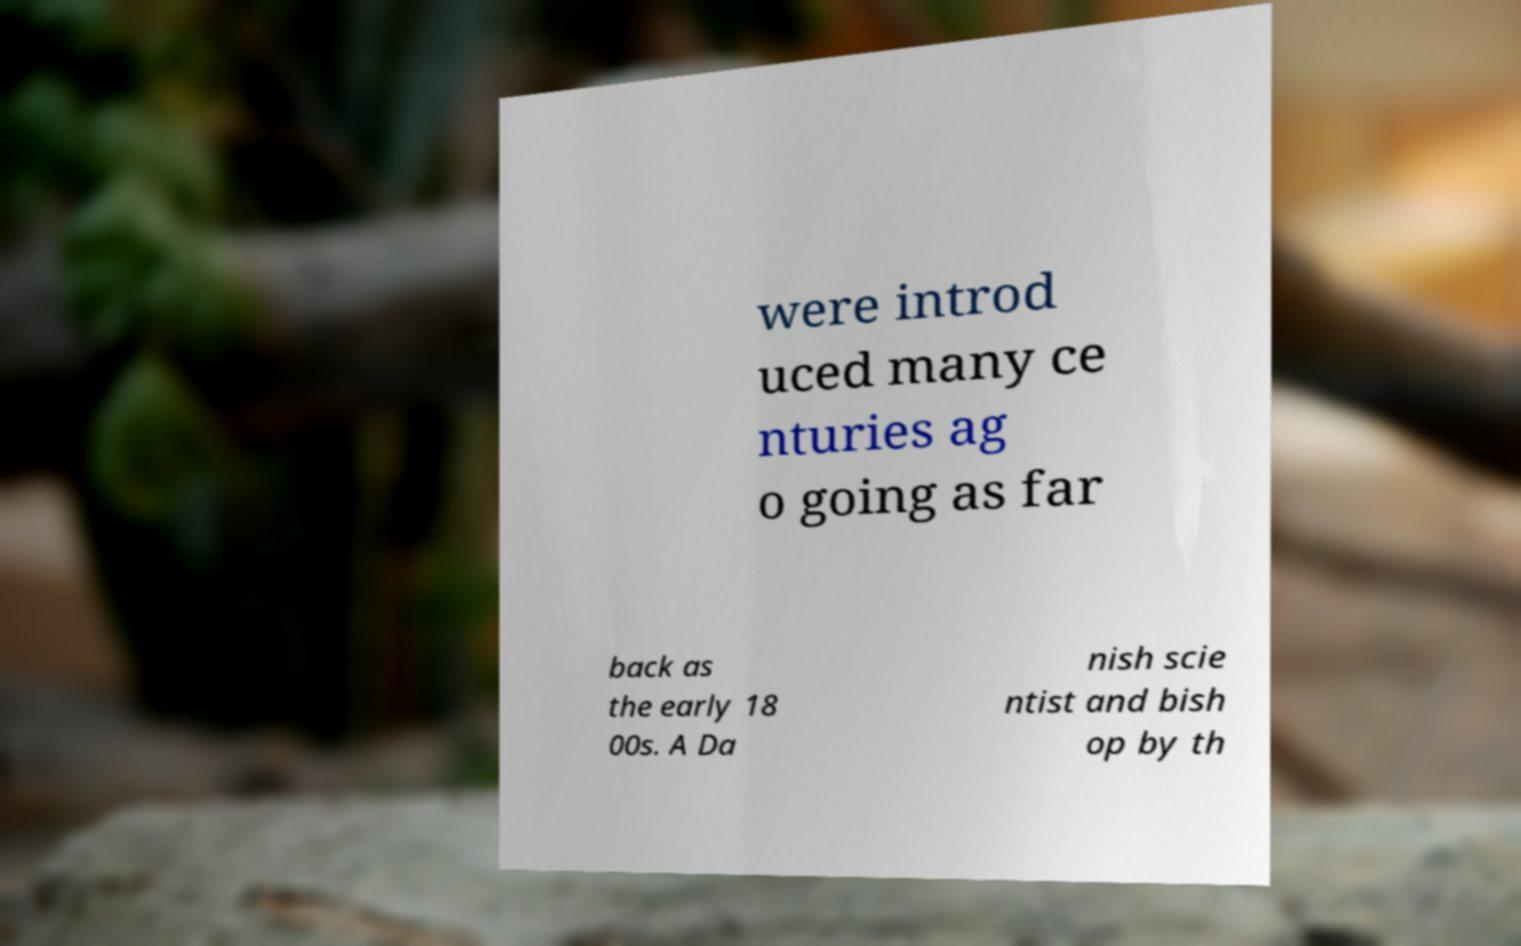Can you accurately transcribe the text from the provided image for me? were introd uced many ce nturies ag o going as far back as the early 18 00s. A Da nish scie ntist and bish op by th 